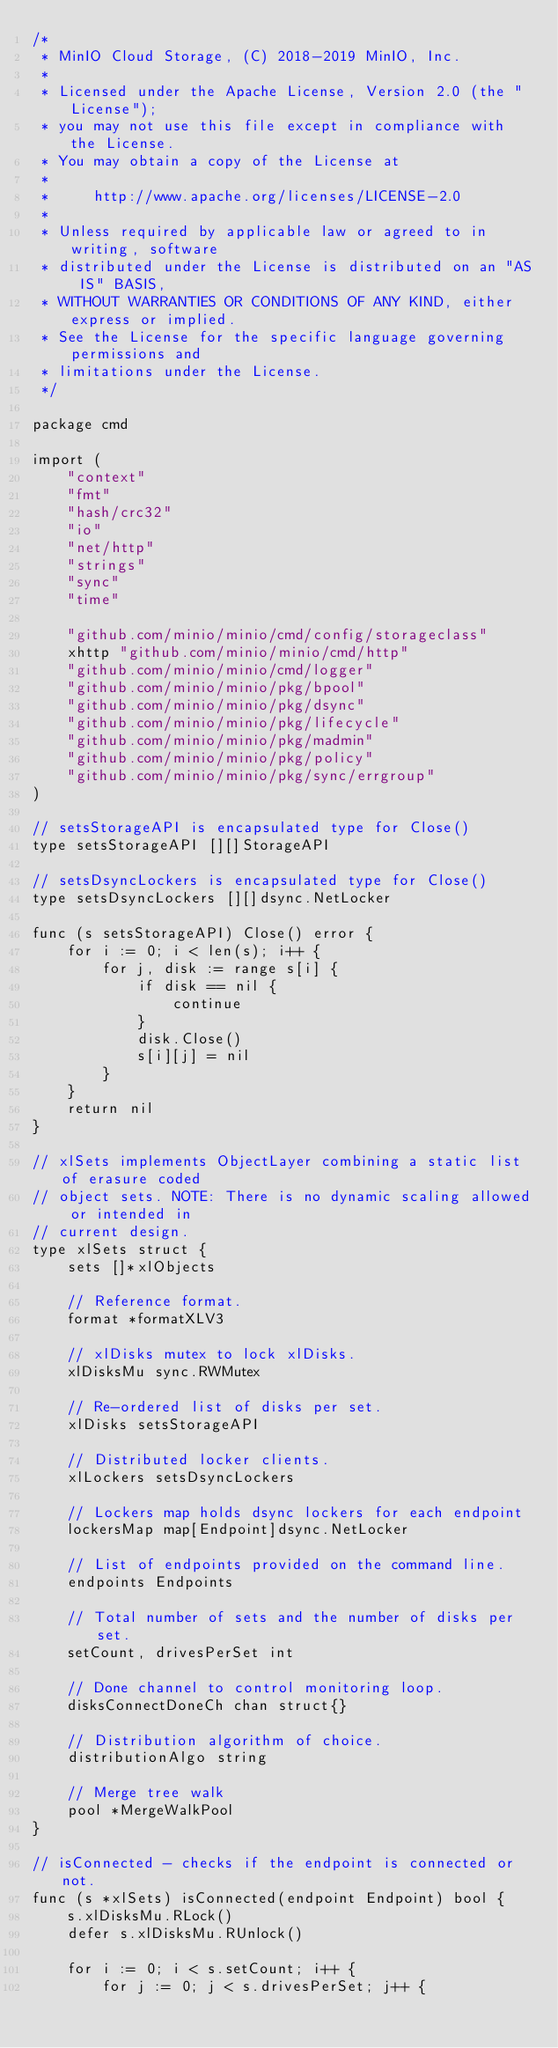Convert code to text. <code><loc_0><loc_0><loc_500><loc_500><_Go_>/*
 * MinIO Cloud Storage, (C) 2018-2019 MinIO, Inc.
 *
 * Licensed under the Apache License, Version 2.0 (the "License");
 * you may not use this file except in compliance with the License.
 * You may obtain a copy of the License at
 *
 *     http://www.apache.org/licenses/LICENSE-2.0
 *
 * Unless required by applicable law or agreed to in writing, software
 * distributed under the License is distributed on an "AS IS" BASIS,
 * WITHOUT WARRANTIES OR CONDITIONS OF ANY KIND, either express or implied.
 * See the License for the specific language governing permissions and
 * limitations under the License.
 */

package cmd

import (
	"context"
	"fmt"
	"hash/crc32"
	"io"
	"net/http"
	"strings"
	"sync"
	"time"

	"github.com/minio/minio/cmd/config/storageclass"
	xhttp "github.com/minio/minio/cmd/http"
	"github.com/minio/minio/cmd/logger"
	"github.com/minio/minio/pkg/bpool"
	"github.com/minio/minio/pkg/dsync"
	"github.com/minio/minio/pkg/lifecycle"
	"github.com/minio/minio/pkg/madmin"
	"github.com/minio/minio/pkg/policy"
	"github.com/minio/minio/pkg/sync/errgroup"
)

// setsStorageAPI is encapsulated type for Close()
type setsStorageAPI [][]StorageAPI

// setsDsyncLockers is encapsulated type for Close()
type setsDsyncLockers [][]dsync.NetLocker

func (s setsStorageAPI) Close() error {
	for i := 0; i < len(s); i++ {
		for j, disk := range s[i] {
			if disk == nil {
				continue
			}
			disk.Close()
			s[i][j] = nil
		}
	}
	return nil
}

// xlSets implements ObjectLayer combining a static list of erasure coded
// object sets. NOTE: There is no dynamic scaling allowed or intended in
// current design.
type xlSets struct {
	sets []*xlObjects

	// Reference format.
	format *formatXLV3

	// xlDisks mutex to lock xlDisks.
	xlDisksMu sync.RWMutex

	// Re-ordered list of disks per set.
	xlDisks setsStorageAPI

	// Distributed locker clients.
	xlLockers setsDsyncLockers

	// Lockers map holds dsync lockers for each endpoint
	lockersMap map[Endpoint]dsync.NetLocker

	// List of endpoints provided on the command line.
	endpoints Endpoints

	// Total number of sets and the number of disks per set.
	setCount, drivesPerSet int

	// Done channel to control monitoring loop.
	disksConnectDoneCh chan struct{}

	// Distribution algorithm of choice.
	distributionAlgo string

	// Merge tree walk
	pool *MergeWalkPool
}

// isConnected - checks if the endpoint is connected or not.
func (s *xlSets) isConnected(endpoint Endpoint) bool {
	s.xlDisksMu.RLock()
	defer s.xlDisksMu.RUnlock()

	for i := 0; i < s.setCount; i++ {
		for j := 0; j < s.drivesPerSet; j++ {</code> 